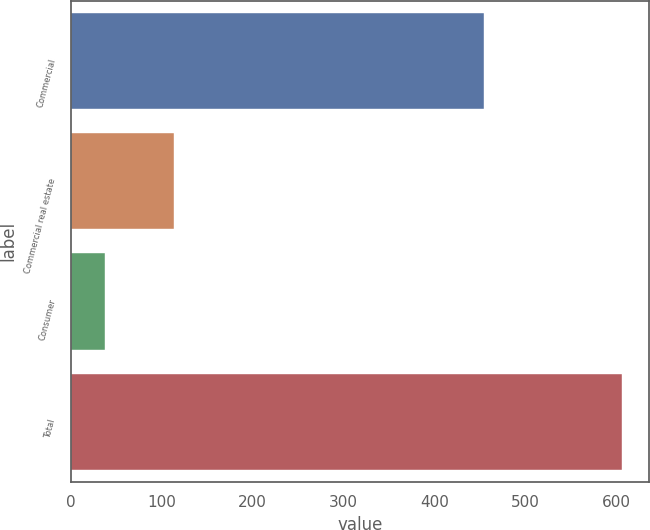Convert chart to OTSL. <chart><loc_0><loc_0><loc_500><loc_500><bar_chart><fcel>Commercial<fcel>Commercial real estate<fcel>Consumer<fcel>Total<nl><fcel>454<fcel>114<fcel>38<fcel>606<nl></chart> 